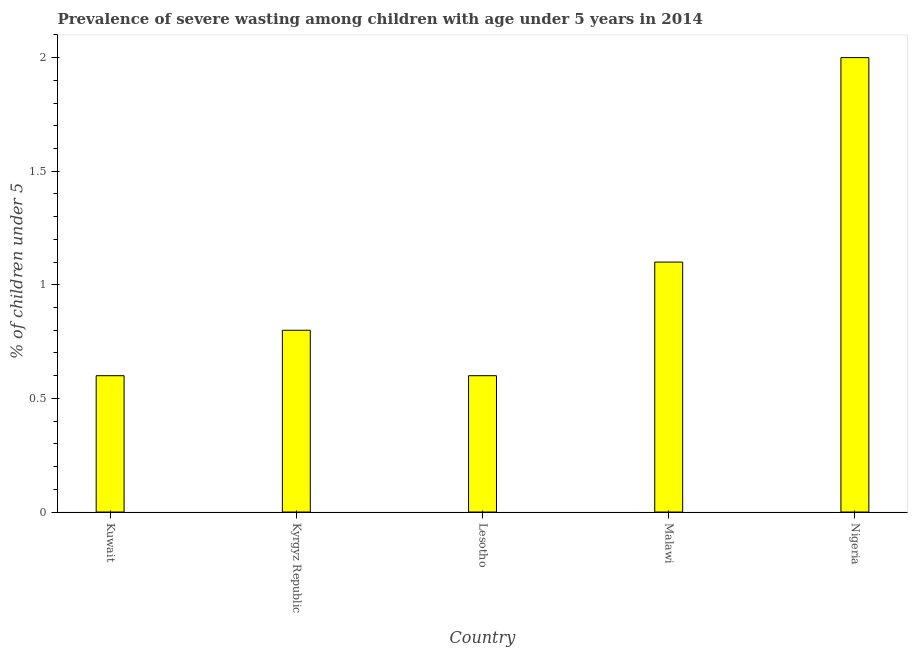Does the graph contain grids?
Your response must be concise. No. What is the title of the graph?
Your response must be concise. Prevalence of severe wasting among children with age under 5 years in 2014. What is the label or title of the X-axis?
Your answer should be compact. Country. What is the label or title of the Y-axis?
Your answer should be very brief.  % of children under 5. What is the prevalence of severe wasting in Kuwait?
Your answer should be very brief. 0.6. Across all countries, what is the maximum prevalence of severe wasting?
Ensure brevity in your answer.  2. Across all countries, what is the minimum prevalence of severe wasting?
Offer a terse response. 0.6. In which country was the prevalence of severe wasting maximum?
Provide a succinct answer. Nigeria. In which country was the prevalence of severe wasting minimum?
Make the answer very short. Kuwait. What is the sum of the prevalence of severe wasting?
Make the answer very short. 5.1. What is the difference between the prevalence of severe wasting in Kyrgyz Republic and Nigeria?
Offer a terse response. -1.2. What is the average prevalence of severe wasting per country?
Keep it short and to the point. 1.02. What is the median prevalence of severe wasting?
Keep it short and to the point. 0.8. In how many countries, is the prevalence of severe wasting greater than 1.4 %?
Offer a terse response. 1. What is the difference between the highest and the second highest prevalence of severe wasting?
Provide a short and direct response. 0.9. Is the sum of the prevalence of severe wasting in Kuwait and Malawi greater than the maximum prevalence of severe wasting across all countries?
Make the answer very short. No. How many countries are there in the graph?
Give a very brief answer. 5. What is the difference between two consecutive major ticks on the Y-axis?
Provide a short and direct response. 0.5. What is the  % of children under 5 in Kuwait?
Offer a very short reply. 0.6. What is the  % of children under 5 of Kyrgyz Republic?
Your answer should be compact. 0.8. What is the  % of children under 5 of Lesotho?
Your answer should be compact. 0.6. What is the  % of children under 5 in Malawi?
Your answer should be very brief. 1.1. What is the  % of children under 5 in Nigeria?
Your response must be concise. 2. What is the difference between the  % of children under 5 in Kuwait and Malawi?
Make the answer very short. -0.5. What is the difference between the  % of children under 5 in Kyrgyz Republic and Lesotho?
Give a very brief answer. 0.2. What is the difference between the  % of children under 5 in Kyrgyz Republic and Malawi?
Keep it short and to the point. -0.3. What is the difference between the  % of children under 5 in Lesotho and Nigeria?
Offer a terse response. -1.4. What is the ratio of the  % of children under 5 in Kuwait to that in Malawi?
Your answer should be very brief. 0.55. What is the ratio of the  % of children under 5 in Kuwait to that in Nigeria?
Your response must be concise. 0.3. What is the ratio of the  % of children under 5 in Kyrgyz Republic to that in Lesotho?
Your response must be concise. 1.33. What is the ratio of the  % of children under 5 in Kyrgyz Republic to that in Malawi?
Give a very brief answer. 0.73. What is the ratio of the  % of children under 5 in Lesotho to that in Malawi?
Your answer should be very brief. 0.55. What is the ratio of the  % of children under 5 in Lesotho to that in Nigeria?
Offer a very short reply. 0.3. What is the ratio of the  % of children under 5 in Malawi to that in Nigeria?
Provide a short and direct response. 0.55. 